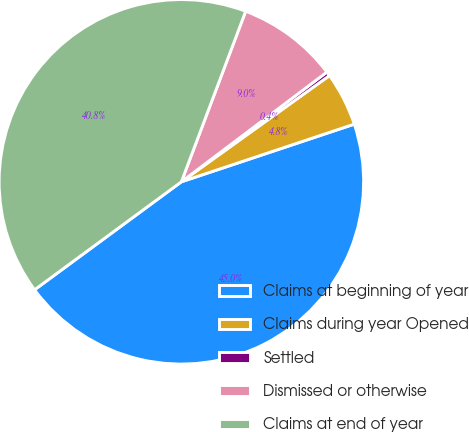Convert chart. <chart><loc_0><loc_0><loc_500><loc_500><pie_chart><fcel>Claims at beginning of year<fcel>Claims during year Opened<fcel>Settled<fcel>Dismissed or otherwise<fcel>Claims at end of year<nl><fcel>45.03%<fcel>4.78%<fcel>0.38%<fcel>8.98%<fcel>40.83%<nl></chart> 